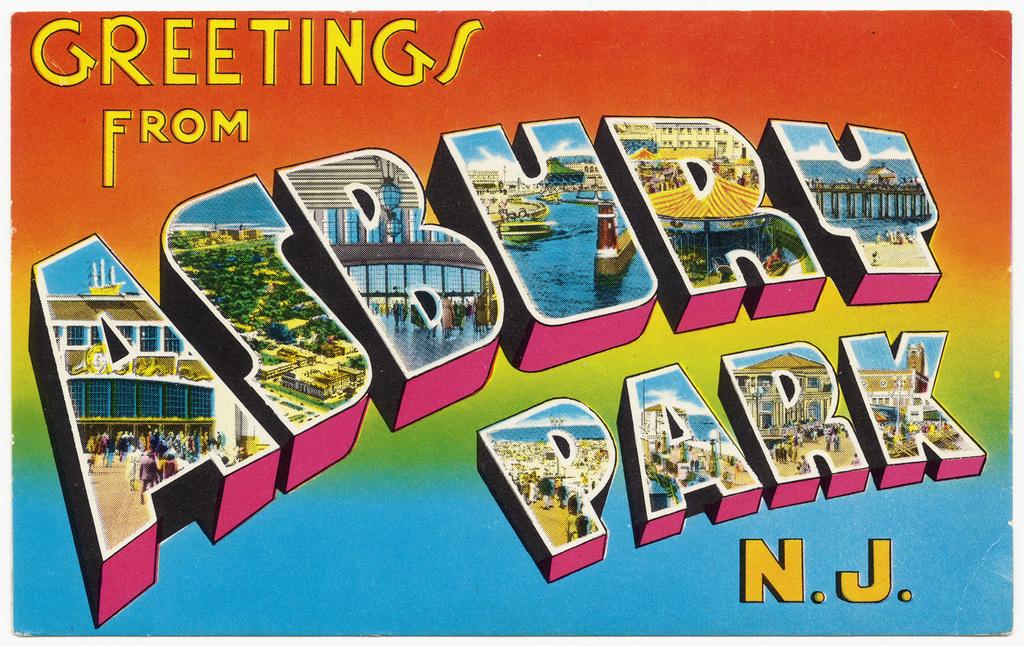What ad is that?
Offer a terse response. Asbury park. Where are they giving greetings from?
Make the answer very short. Asbury park n.j. 